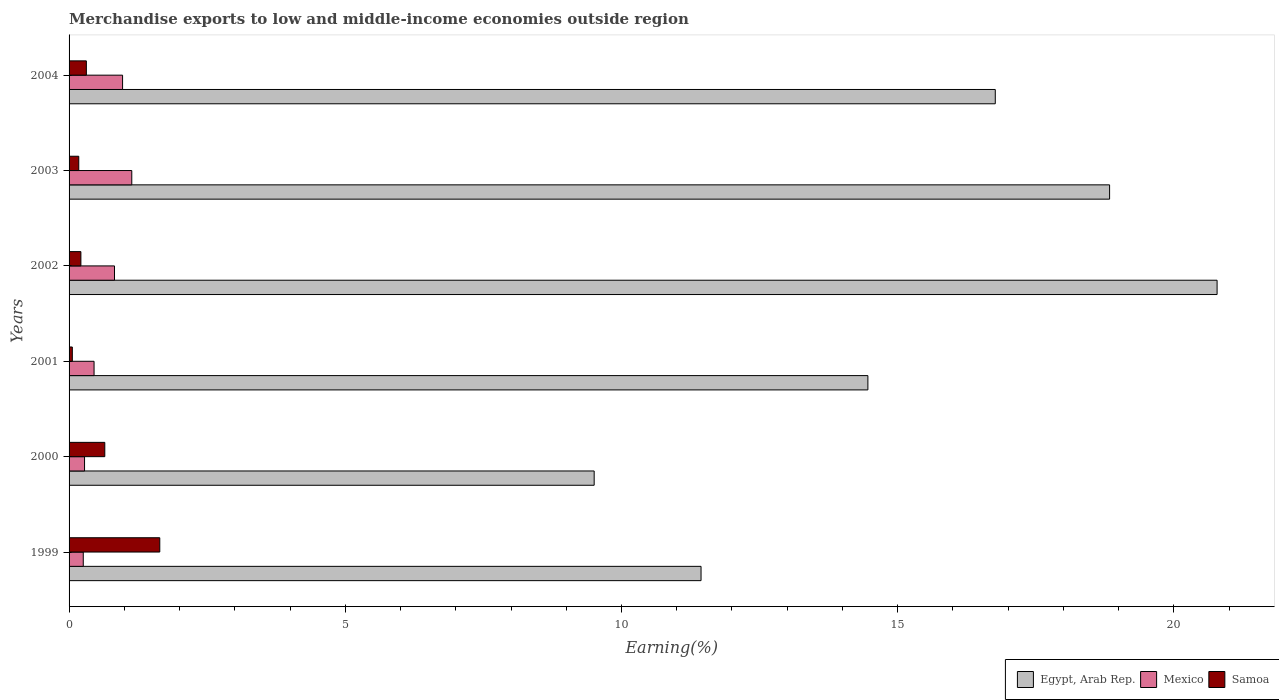How many groups of bars are there?
Your answer should be very brief. 6. Are the number of bars per tick equal to the number of legend labels?
Your response must be concise. Yes. How many bars are there on the 1st tick from the top?
Offer a terse response. 3. How many bars are there on the 6th tick from the bottom?
Your response must be concise. 3. What is the label of the 3rd group of bars from the top?
Offer a very short reply. 2002. In how many cases, is the number of bars for a given year not equal to the number of legend labels?
Provide a succinct answer. 0. What is the percentage of amount earned from merchandise exports in Egypt, Arab Rep. in 2000?
Make the answer very short. 9.51. Across all years, what is the maximum percentage of amount earned from merchandise exports in Samoa?
Your answer should be very brief. 1.64. Across all years, what is the minimum percentage of amount earned from merchandise exports in Mexico?
Ensure brevity in your answer.  0.26. In which year was the percentage of amount earned from merchandise exports in Samoa maximum?
Your answer should be compact. 1999. What is the total percentage of amount earned from merchandise exports in Mexico in the graph?
Your answer should be very brief. 3.92. What is the difference between the percentage of amount earned from merchandise exports in Mexico in 2001 and that in 2004?
Your answer should be very brief. -0.52. What is the difference between the percentage of amount earned from merchandise exports in Samoa in 2001 and the percentage of amount earned from merchandise exports in Mexico in 2002?
Your answer should be very brief. -0.76. What is the average percentage of amount earned from merchandise exports in Mexico per year?
Provide a short and direct response. 0.65. In the year 2003, what is the difference between the percentage of amount earned from merchandise exports in Egypt, Arab Rep. and percentage of amount earned from merchandise exports in Mexico?
Offer a terse response. 17.7. What is the ratio of the percentage of amount earned from merchandise exports in Egypt, Arab Rep. in 2000 to that in 2001?
Make the answer very short. 0.66. What is the difference between the highest and the second highest percentage of amount earned from merchandise exports in Egypt, Arab Rep.?
Ensure brevity in your answer.  1.95. What is the difference between the highest and the lowest percentage of amount earned from merchandise exports in Egypt, Arab Rep.?
Offer a terse response. 11.28. Is the sum of the percentage of amount earned from merchandise exports in Samoa in 1999 and 2002 greater than the maximum percentage of amount earned from merchandise exports in Mexico across all years?
Give a very brief answer. Yes. What does the 2nd bar from the top in 1999 represents?
Keep it short and to the point. Mexico. What does the 3rd bar from the bottom in 2001 represents?
Offer a very short reply. Samoa. Is it the case that in every year, the sum of the percentage of amount earned from merchandise exports in Samoa and percentage of amount earned from merchandise exports in Mexico is greater than the percentage of amount earned from merchandise exports in Egypt, Arab Rep.?
Your response must be concise. No. How many bars are there?
Offer a very short reply. 18. Are all the bars in the graph horizontal?
Make the answer very short. Yes. Are the values on the major ticks of X-axis written in scientific E-notation?
Ensure brevity in your answer.  No. Does the graph contain any zero values?
Offer a terse response. No. How many legend labels are there?
Your response must be concise. 3. What is the title of the graph?
Ensure brevity in your answer.  Merchandise exports to low and middle-income economies outside region. Does "Ireland" appear as one of the legend labels in the graph?
Make the answer very short. No. What is the label or title of the X-axis?
Provide a short and direct response. Earning(%). What is the label or title of the Y-axis?
Provide a succinct answer. Years. What is the Earning(%) in Egypt, Arab Rep. in 1999?
Provide a short and direct response. 11.44. What is the Earning(%) of Mexico in 1999?
Give a very brief answer. 0.26. What is the Earning(%) in Samoa in 1999?
Provide a short and direct response. 1.64. What is the Earning(%) in Egypt, Arab Rep. in 2000?
Your answer should be very brief. 9.51. What is the Earning(%) in Mexico in 2000?
Your response must be concise. 0.28. What is the Earning(%) in Samoa in 2000?
Provide a succinct answer. 0.65. What is the Earning(%) of Egypt, Arab Rep. in 2001?
Your answer should be very brief. 14.46. What is the Earning(%) of Mexico in 2001?
Offer a very short reply. 0.45. What is the Earning(%) of Samoa in 2001?
Offer a very short reply. 0.06. What is the Earning(%) in Egypt, Arab Rep. in 2002?
Your answer should be very brief. 20.78. What is the Earning(%) of Mexico in 2002?
Your response must be concise. 0.82. What is the Earning(%) in Samoa in 2002?
Keep it short and to the point. 0.21. What is the Earning(%) in Egypt, Arab Rep. in 2003?
Your answer should be compact. 18.84. What is the Earning(%) of Mexico in 2003?
Provide a succinct answer. 1.14. What is the Earning(%) of Samoa in 2003?
Provide a succinct answer. 0.18. What is the Earning(%) of Egypt, Arab Rep. in 2004?
Keep it short and to the point. 16.77. What is the Earning(%) of Mexico in 2004?
Your response must be concise. 0.97. What is the Earning(%) in Samoa in 2004?
Ensure brevity in your answer.  0.31. Across all years, what is the maximum Earning(%) of Egypt, Arab Rep.?
Provide a succinct answer. 20.78. Across all years, what is the maximum Earning(%) in Mexico?
Offer a terse response. 1.14. Across all years, what is the maximum Earning(%) of Samoa?
Offer a very short reply. 1.64. Across all years, what is the minimum Earning(%) in Egypt, Arab Rep.?
Offer a terse response. 9.51. Across all years, what is the minimum Earning(%) of Mexico?
Provide a succinct answer. 0.26. Across all years, what is the minimum Earning(%) of Samoa?
Offer a terse response. 0.06. What is the total Earning(%) in Egypt, Arab Rep. in the graph?
Ensure brevity in your answer.  91.79. What is the total Earning(%) of Mexico in the graph?
Ensure brevity in your answer.  3.92. What is the total Earning(%) of Samoa in the graph?
Your answer should be very brief. 3.05. What is the difference between the Earning(%) in Egypt, Arab Rep. in 1999 and that in 2000?
Ensure brevity in your answer.  1.93. What is the difference between the Earning(%) of Mexico in 1999 and that in 2000?
Keep it short and to the point. -0.02. What is the difference between the Earning(%) of Egypt, Arab Rep. in 1999 and that in 2001?
Keep it short and to the point. -3.02. What is the difference between the Earning(%) of Mexico in 1999 and that in 2001?
Offer a terse response. -0.2. What is the difference between the Earning(%) in Samoa in 1999 and that in 2001?
Offer a very short reply. 1.58. What is the difference between the Earning(%) in Egypt, Arab Rep. in 1999 and that in 2002?
Your answer should be compact. -9.34. What is the difference between the Earning(%) in Mexico in 1999 and that in 2002?
Give a very brief answer. -0.57. What is the difference between the Earning(%) of Samoa in 1999 and that in 2002?
Keep it short and to the point. 1.43. What is the difference between the Earning(%) in Egypt, Arab Rep. in 1999 and that in 2003?
Give a very brief answer. -7.4. What is the difference between the Earning(%) of Mexico in 1999 and that in 2003?
Make the answer very short. -0.88. What is the difference between the Earning(%) of Samoa in 1999 and that in 2003?
Provide a succinct answer. 1.47. What is the difference between the Earning(%) in Egypt, Arab Rep. in 1999 and that in 2004?
Offer a terse response. -5.33. What is the difference between the Earning(%) of Mexico in 1999 and that in 2004?
Your answer should be compact. -0.71. What is the difference between the Earning(%) of Samoa in 1999 and that in 2004?
Keep it short and to the point. 1.33. What is the difference between the Earning(%) of Egypt, Arab Rep. in 2000 and that in 2001?
Your answer should be very brief. -4.96. What is the difference between the Earning(%) in Mexico in 2000 and that in 2001?
Your response must be concise. -0.17. What is the difference between the Earning(%) of Samoa in 2000 and that in 2001?
Offer a terse response. 0.59. What is the difference between the Earning(%) in Egypt, Arab Rep. in 2000 and that in 2002?
Offer a terse response. -11.28. What is the difference between the Earning(%) of Mexico in 2000 and that in 2002?
Provide a short and direct response. -0.54. What is the difference between the Earning(%) of Samoa in 2000 and that in 2002?
Ensure brevity in your answer.  0.43. What is the difference between the Earning(%) in Egypt, Arab Rep. in 2000 and that in 2003?
Offer a very short reply. -9.33. What is the difference between the Earning(%) in Mexico in 2000 and that in 2003?
Your answer should be compact. -0.85. What is the difference between the Earning(%) of Samoa in 2000 and that in 2003?
Keep it short and to the point. 0.47. What is the difference between the Earning(%) of Egypt, Arab Rep. in 2000 and that in 2004?
Offer a terse response. -7.26. What is the difference between the Earning(%) in Mexico in 2000 and that in 2004?
Make the answer very short. -0.69. What is the difference between the Earning(%) of Samoa in 2000 and that in 2004?
Ensure brevity in your answer.  0.33. What is the difference between the Earning(%) in Egypt, Arab Rep. in 2001 and that in 2002?
Your response must be concise. -6.32. What is the difference between the Earning(%) of Mexico in 2001 and that in 2002?
Ensure brevity in your answer.  -0.37. What is the difference between the Earning(%) of Samoa in 2001 and that in 2002?
Offer a very short reply. -0.15. What is the difference between the Earning(%) of Egypt, Arab Rep. in 2001 and that in 2003?
Keep it short and to the point. -4.38. What is the difference between the Earning(%) in Mexico in 2001 and that in 2003?
Your answer should be very brief. -0.68. What is the difference between the Earning(%) of Samoa in 2001 and that in 2003?
Your answer should be compact. -0.12. What is the difference between the Earning(%) of Egypt, Arab Rep. in 2001 and that in 2004?
Make the answer very short. -2.31. What is the difference between the Earning(%) in Mexico in 2001 and that in 2004?
Offer a terse response. -0.52. What is the difference between the Earning(%) in Samoa in 2001 and that in 2004?
Your response must be concise. -0.25. What is the difference between the Earning(%) in Egypt, Arab Rep. in 2002 and that in 2003?
Your response must be concise. 1.95. What is the difference between the Earning(%) of Mexico in 2002 and that in 2003?
Provide a short and direct response. -0.31. What is the difference between the Earning(%) of Samoa in 2002 and that in 2003?
Offer a very short reply. 0.04. What is the difference between the Earning(%) in Egypt, Arab Rep. in 2002 and that in 2004?
Your answer should be very brief. 4.02. What is the difference between the Earning(%) of Mexico in 2002 and that in 2004?
Your response must be concise. -0.15. What is the difference between the Earning(%) in Samoa in 2002 and that in 2004?
Your answer should be very brief. -0.1. What is the difference between the Earning(%) in Egypt, Arab Rep. in 2003 and that in 2004?
Your answer should be compact. 2.07. What is the difference between the Earning(%) in Mexico in 2003 and that in 2004?
Make the answer very short. 0.17. What is the difference between the Earning(%) of Samoa in 2003 and that in 2004?
Ensure brevity in your answer.  -0.14. What is the difference between the Earning(%) of Egypt, Arab Rep. in 1999 and the Earning(%) of Mexico in 2000?
Offer a terse response. 11.16. What is the difference between the Earning(%) in Egypt, Arab Rep. in 1999 and the Earning(%) in Samoa in 2000?
Give a very brief answer. 10.79. What is the difference between the Earning(%) in Mexico in 1999 and the Earning(%) in Samoa in 2000?
Provide a short and direct response. -0.39. What is the difference between the Earning(%) in Egypt, Arab Rep. in 1999 and the Earning(%) in Mexico in 2001?
Give a very brief answer. 10.99. What is the difference between the Earning(%) of Egypt, Arab Rep. in 1999 and the Earning(%) of Samoa in 2001?
Your response must be concise. 11.38. What is the difference between the Earning(%) of Mexico in 1999 and the Earning(%) of Samoa in 2001?
Your response must be concise. 0.2. What is the difference between the Earning(%) of Egypt, Arab Rep. in 1999 and the Earning(%) of Mexico in 2002?
Provide a short and direct response. 10.62. What is the difference between the Earning(%) of Egypt, Arab Rep. in 1999 and the Earning(%) of Samoa in 2002?
Provide a succinct answer. 11.23. What is the difference between the Earning(%) in Mexico in 1999 and the Earning(%) in Samoa in 2002?
Provide a short and direct response. 0.04. What is the difference between the Earning(%) of Egypt, Arab Rep. in 1999 and the Earning(%) of Mexico in 2003?
Your response must be concise. 10.31. What is the difference between the Earning(%) in Egypt, Arab Rep. in 1999 and the Earning(%) in Samoa in 2003?
Provide a short and direct response. 11.26. What is the difference between the Earning(%) of Mexico in 1999 and the Earning(%) of Samoa in 2003?
Keep it short and to the point. 0.08. What is the difference between the Earning(%) of Egypt, Arab Rep. in 1999 and the Earning(%) of Mexico in 2004?
Offer a terse response. 10.47. What is the difference between the Earning(%) in Egypt, Arab Rep. in 1999 and the Earning(%) in Samoa in 2004?
Ensure brevity in your answer.  11.13. What is the difference between the Earning(%) of Mexico in 1999 and the Earning(%) of Samoa in 2004?
Provide a succinct answer. -0.06. What is the difference between the Earning(%) in Egypt, Arab Rep. in 2000 and the Earning(%) in Mexico in 2001?
Keep it short and to the point. 9.05. What is the difference between the Earning(%) of Egypt, Arab Rep. in 2000 and the Earning(%) of Samoa in 2001?
Make the answer very short. 9.45. What is the difference between the Earning(%) in Mexico in 2000 and the Earning(%) in Samoa in 2001?
Your response must be concise. 0.22. What is the difference between the Earning(%) in Egypt, Arab Rep. in 2000 and the Earning(%) in Mexico in 2002?
Your answer should be compact. 8.68. What is the difference between the Earning(%) of Egypt, Arab Rep. in 2000 and the Earning(%) of Samoa in 2002?
Your answer should be compact. 9.29. What is the difference between the Earning(%) of Mexico in 2000 and the Earning(%) of Samoa in 2002?
Give a very brief answer. 0.07. What is the difference between the Earning(%) in Egypt, Arab Rep. in 2000 and the Earning(%) in Mexico in 2003?
Offer a very short reply. 8.37. What is the difference between the Earning(%) in Egypt, Arab Rep. in 2000 and the Earning(%) in Samoa in 2003?
Provide a short and direct response. 9.33. What is the difference between the Earning(%) in Mexico in 2000 and the Earning(%) in Samoa in 2003?
Give a very brief answer. 0.1. What is the difference between the Earning(%) of Egypt, Arab Rep. in 2000 and the Earning(%) of Mexico in 2004?
Your response must be concise. 8.54. What is the difference between the Earning(%) of Egypt, Arab Rep. in 2000 and the Earning(%) of Samoa in 2004?
Offer a very short reply. 9.19. What is the difference between the Earning(%) of Mexico in 2000 and the Earning(%) of Samoa in 2004?
Your answer should be compact. -0.03. What is the difference between the Earning(%) in Egypt, Arab Rep. in 2001 and the Earning(%) in Mexico in 2002?
Give a very brief answer. 13.64. What is the difference between the Earning(%) in Egypt, Arab Rep. in 2001 and the Earning(%) in Samoa in 2002?
Provide a short and direct response. 14.25. What is the difference between the Earning(%) of Mexico in 2001 and the Earning(%) of Samoa in 2002?
Ensure brevity in your answer.  0.24. What is the difference between the Earning(%) of Egypt, Arab Rep. in 2001 and the Earning(%) of Mexico in 2003?
Your answer should be compact. 13.33. What is the difference between the Earning(%) in Egypt, Arab Rep. in 2001 and the Earning(%) in Samoa in 2003?
Provide a succinct answer. 14.29. What is the difference between the Earning(%) in Mexico in 2001 and the Earning(%) in Samoa in 2003?
Provide a short and direct response. 0.28. What is the difference between the Earning(%) in Egypt, Arab Rep. in 2001 and the Earning(%) in Mexico in 2004?
Give a very brief answer. 13.49. What is the difference between the Earning(%) of Egypt, Arab Rep. in 2001 and the Earning(%) of Samoa in 2004?
Keep it short and to the point. 14.15. What is the difference between the Earning(%) of Mexico in 2001 and the Earning(%) of Samoa in 2004?
Make the answer very short. 0.14. What is the difference between the Earning(%) in Egypt, Arab Rep. in 2002 and the Earning(%) in Mexico in 2003?
Your answer should be compact. 19.65. What is the difference between the Earning(%) in Egypt, Arab Rep. in 2002 and the Earning(%) in Samoa in 2003?
Offer a very short reply. 20.61. What is the difference between the Earning(%) in Mexico in 2002 and the Earning(%) in Samoa in 2003?
Make the answer very short. 0.65. What is the difference between the Earning(%) of Egypt, Arab Rep. in 2002 and the Earning(%) of Mexico in 2004?
Your answer should be compact. 19.81. What is the difference between the Earning(%) of Egypt, Arab Rep. in 2002 and the Earning(%) of Samoa in 2004?
Your response must be concise. 20.47. What is the difference between the Earning(%) of Mexico in 2002 and the Earning(%) of Samoa in 2004?
Offer a terse response. 0.51. What is the difference between the Earning(%) of Egypt, Arab Rep. in 2003 and the Earning(%) of Mexico in 2004?
Ensure brevity in your answer.  17.87. What is the difference between the Earning(%) in Egypt, Arab Rep. in 2003 and the Earning(%) in Samoa in 2004?
Offer a very short reply. 18.52. What is the difference between the Earning(%) in Mexico in 2003 and the Earning(%) in Samoa in 2004?
Offer a very short reply. 0.82. What is the average Earning(%) in Egypt, Arab Rep. per year?
Your response must be concise. 15.3. What is the average Earning(%) in Mexico per year?
Provide a succinct answer. 0.65. What is the average Earning(%) of Samoa per year?
Ensure brevity in your answer.  0.51. In the year 1999, what is the difference between the Earning(%) of Egypt, Arab Rep. and Earning(%) of Mexico?
Your answer should be very brief. 11.18. In the year 1999, what is the difference between the Earning(%) of Egypt, Arab Rep. and Earning(%) of Samoa?
Your response must be concise. 9.8. In the year 1999, what is the difference between the Earning(%) of Mexico and Earning(%) of Samoa?
Offer a terse response. -1.39. In the year 2000, what is the difference between the Earning(%) in Egypt, Arab Rep. and Earning(%) in Mexico?
Give a very brief answer. 9.23. In the year 2000, what is the difference between the Earning(%) of Egypt, Arab Rep. and Earning(%) of Samoa?
Provide a succinct answer. 8.86. In the year 2000, what is the difference between the Earning(%) in Mexico and Earning(%) in Samoa?
Your response must be concise. -0.37. In the year 2001, what is the difference between the Earning(%) in Egypt, Arab Rep. and Earning(%) in Mexico?
Make the answer very short. 14.01. In the year 2001, what is the difference between the Earning(%) in Egypt, Arab Rep. and Earning(%) in Samoa?
Keep it short and to the point. 14.4. In the year 2001, what is the difference between the Earning(%) in Mexico and Earning(%) in Samoa?
Make the answer very short. 0.39. In the year 2002, what is the difference between the Earning(%) in Egypt, Arab Rep. and Earning(%) in Mexico?
Offer a very short reply. 19.96. In the year 2002, what is the difference between the Earning(%) of Egypt, Arab Rep. and Earning(%) of Samoa?
Provide a succinct answer. 20.57. In the year 2002, what is the difference between the Earning(%) of Mexico and Earning(%) of Samoa?
Your response must be concise. 0.61. In the year 2003, what is the difference between the Earning(%) in Egypt, Arab Rep. and Earning(%) in Mexico?
Ensure brevity in your answer.  17.7. In the year 2003, what is the difference between the Earning(%) in Egypt, Arab Rep. and Earning(%) in Samoa?
Offer a terse response. 18.66. In the year 2003, what is the difference between the Earning(%) in Mexico and Earning(%) in Samoa?
Your answer should be compact. 0.96. In the year 2004, what is the difference between the Earning(%) in Egypt, Arab Rep. and Earning(%) in Mexico?
Make the answer very short. 15.8. In the year 2004, what is the difference between the Earning(%) of Egypt, Arab Rep. and Earning(%) of Samoa?
Offer a terse response. 16.45. In the year 2004, what is the difference between the Earning(%) of Mexico and Earning(%) of Samoa?
Ensure brevity in your answer.  0.66. What is the ratio of the Earning(%) in Egypt, Arab Rep. in 1999 to that in 2000?
Ensure brevity in your answer.  1.2. What is the ratio of the Earning(%) in Mexico in 1999 to that in 2000?
Your answer should be very brief. 0.92. What is the ratio of the Earning(%) in Samoa in 1999 to that in 2000?
Keep it short and to the point. 2.54. What is the ratio of the Earning(%) in Egypt, Arab Rep. in 1999 to that in 2001?
Keep it short and to the point. 0.79. What is the ratio of the Earning(%) of Mexico in 1999 to that in 2001?
Offer a very short reply. 0.57. What is the ratio of the Earning(%) of Samoa in 1999 to that in 2001?
Offer a very short reply. 27.81. What is the ratio of the Earning(%) of Egypt, Arab Rep. in 1999 to that in 2002?
Provide a succinct answer. 0.55. What is the ratio of the Earning(%) of Mexico in 1999 to that in 2002?
Offer a very short reply. 0.31. What is the ratio of the Earning(%) in Samoa in 1999 to that in 2002?
Your response must be concise. 7.67. What is the ratio of the Earning(%) of Egypt, Arab Rep. in 1999 to that in 2003?
Offer a terse response. 0.61. What is the ratio of the Earning(%) of Mexico in 1999 to that in 2003?
Provide a succinct answer. 0.23. What is the ratio of the Earning(%) of Samoa in 1999 to that in 2003?
Provide a short and direct response. 9.36. What is the ratio of the Earning(%) in Egypt, Arab Rep. in 1999 to that in 2004?
Offer a very short reply. 0.68. What is the ratio of the Earning(%) of Mexico in 1999 to that in 2004?
Provide a short and direct response. 0.27. What is the ratio of the Earning(%) in Samoa in 1999 to that in 2004?
Keep it short and to the point. 5.24. What is the ratio of the Earning(%) in Egypt, Arab Rep. in 2000 to that in 2001?
Your answer should be very brief. 0.66. What is the ratio of the Earning(%) in Mexico in 2000 to that in 2001?
Ensure brevity in your answer.  0.62. What is the ratio of the Earning(%) of Samoa in 2000 to that in 2001?
Provide a short and direct response. 10.95. What is the ratio of the Earning(%) of Egypt, Arab Rep. in 2000 to that in 2002?
Provide a succinct answer. 0.46. What is the ratio of the Earning(%) of Mexico in 2000 to that in 2002?
Your response must be concise. 0.34. What is the ratio of the Earning(%) of Samoa in 2000 to that in 2002?
Provide a succinct answer. 3.02. What is the ratio of the Earning(%) in Egypt, Arab Rep. in 2000 to that in 2003?
Your answer should be very brief. 0.5. What is the ratio of the Earning(%) of Mexico in 2000 to that in 2003?
Make the answer very short. 0.25. What is the ratio of the Earning(%) in Samoa in 2000 to that in 2003?
Your answer should be compact. 3.68. What is the ratio of the Earning(%) in Egypt, Arab Rep. in 2000 to that in 2004?
Your answer should be compact. 0.57. What is the ratio of the Earning(%) of Mexico in 2000 to that in 2004?
Give a very brief answer. 0.29. What is the ratio of the Earning(%) in Samoa in 2000 to that in 2004?
Your answer should be compact. 2.07. What is the ratio of the Earning(%) of Egypt, Arab Rep. in 2001 to that in 2002?
Ensure brevity in your answer.  0.7. What is the ratio of the Earning(%) of Mexico in 2001 to that in 2002?
Offer a terse response. 0.55. What is the ratio of the Earning(%) in Samoa in 2001 to that in 2002?
Give a very brief answer. 0.28. What is the ratio of the Earning(%) of Egypt, Arab Rep. in 2001 to that in 2003?
Your answer should be very brief. 0.77. What is the ratio of the Earning(%) in Mexico in 2001 to that in 2003?
Provide a short and direct response. 0.4. What is the ratio of the Earning(%) of Samoa in 2001 to that in 2003?
Your answer should be compact. 0.34. What is the ratio of the Earning(%) of Egypt, Arab Rep. in 2001 to that in 2004?
Your answer should be compact. 0.86. What is the ratio of the Earning(%) of Mexico in 2001 to that in 2004?
Offer a terse response. 0.47. What is the ratio of the Earning(%) in Samoa in 2001 to that in 2004?
Your answer should be compact. 0.19. What is the ratio of the Earning(%) in Egypt, Arab Rep. in 2002 to that in 2003?
Your response must be concise. 1.1. What is the ratio of the Earning(%) of Mexico in 2002 to that in 2003?
Offer a very short reply. 0.72. What is the ratio of the Earning(%) of Samoa in 2002 to that in 2003?
Your response must be concise. 1.22. What is the ratio of the Earning(%) in Egypt, Arab Rep. in 2002 to that in 2004?
Ensure brevity in your answer.  1.24. What is the ratio of the Earning(%) in Mexico in 2002 to that in 2004?
Offer a terse response. 0.85. What is the ratio of the Earning(%) in Samoa in 2002 to that in 2004?
Keep it short and to the point. 0.68. What is the ratio of the Earning(%) of Egypt, Arab Rep. in 2003 to that in 2004?
Offer a very short reply. 1.12. What is the ratio of the Earning(%) in Mexico in 2003 to that in 2004?
Offer a very short reply. 1.17. What is the ratio of the Earning(%) of Samoa in 2003 to that in 2004?
Provide a short and direct response. 0.56. What is the difference between the highest and the second highest Earning(%) in Egypt, Arab Rep.?
Your answer should be compact. 1.95. What is the difference between the highest and the second highest Earning(%) in Mexico?
Offer a very short reply. 0.17. What is the difference between the highest and the lowest Earning(%) in Egypt, Arab Rep.?
Give a very brief answer. 11.28. What is the difference between the highest and the lowest Earning(%) in Mexico?
Ensure brevity in your answer.  0.88. What is the difference between the highest and the lowest Earning(%) of Samoa?
Keep it short and to the point. 1.58. 